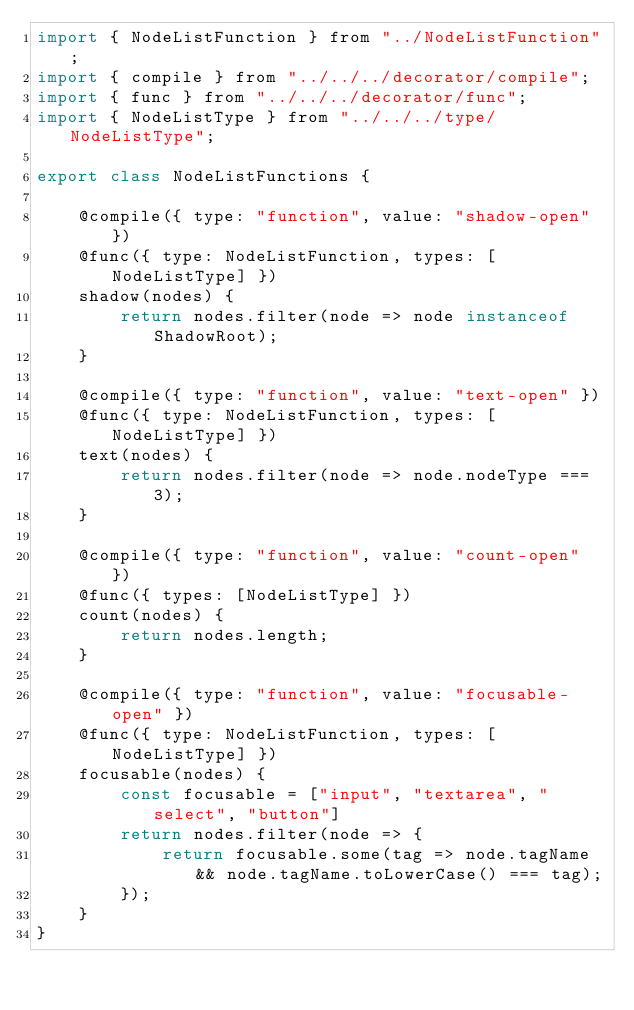Convert code to text. <code><loc_0><loc_0><loc_500><loc_500><_JavaScript_>import { NodeListFunction } from "../NodeListFunction";
import { compile } from "../../../decorator/compile";
import { func } from "../../../decorator/func";
import { NodeListType } from "../../../type/NodeListType";

export class NodeListFunctions {

    @compile({ type: "function", value: "shadow-open" })
    @func({ type: NodeListFunction, types: [NodeListType] })
    shadow(nodes) {
        return nodes.filter(node => node instanceof ShadowRoot);
    }

    @compile({ type: "function", value: "text-open" })
    @func({ type: NodeListFunction, types: [NodeListType] })
    text(nodes) {
        return nodes.filter(node => node.nodeType === 3);
    }

    @compile({ type: "function", value: "count-open" })
    @func({ types: [NodeListType] })
    count(nodes) {
        return nodes.length;
    }

    @compile({ type: "function", value: "focusable-open" })
    @func({ type: NodeListFunction, types: [NodeListType] })
    focusable(nodes) {
        const focusable = ["input", "textarea", "select", "button"]
        return nodes.filter(node => {
            return focusable.some(tag => node.tagName && node.tagName.toLowerCase() === tag);
        });
    }
}</code> 